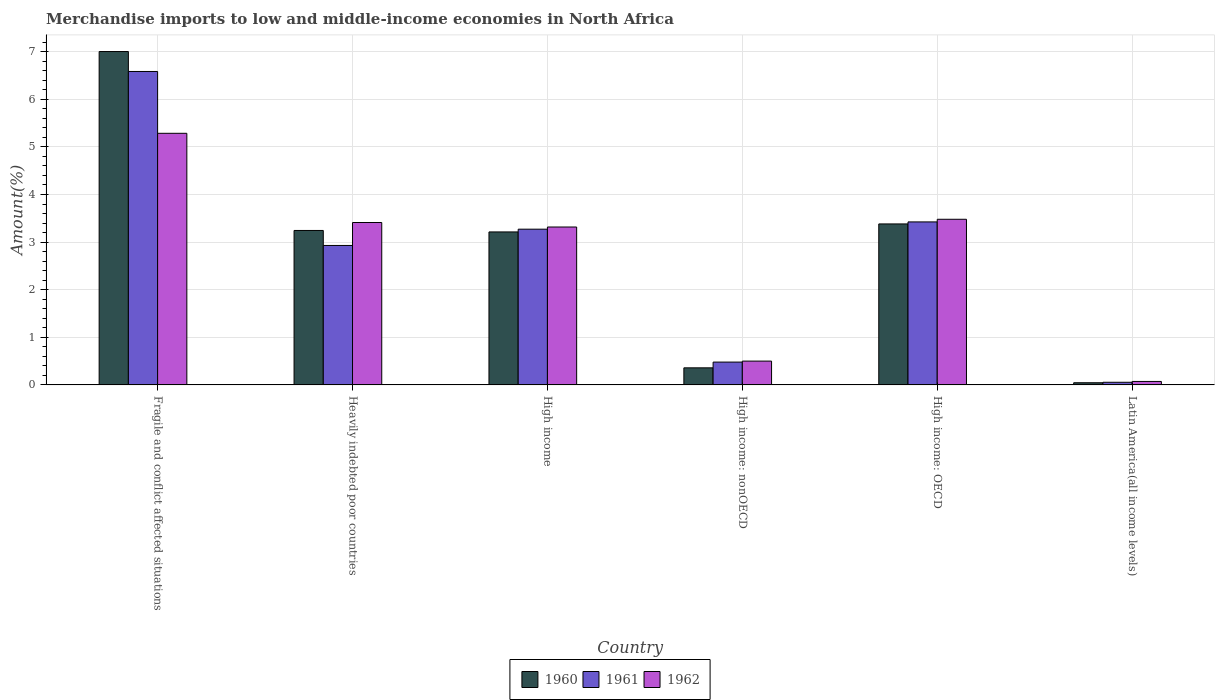Are the number of bars per tick equal to the number of legend labels?
Make the answer very short. Yes. How many bars are there on the 3rd tick from the right?
Give a very brief answer. 3. What is the label of the 5th group of bars from the left?
Keep it short and to the point. High income: OECD. In how many cases, is the number of bars for a given country not equal to the number of legend labels?
Your answer should be very brief. 0. What is the percentage of amount earned from merchandise imports in 1960 in Fragile and conflict affected situations?
Keep it short and to the point. 7. Across all countries, what is the maximum percentage of amount earned from merchandise imports in 1960?
Offer a terse response. 7. Across all countries, what is the minimum percentage of amount earned from merchandise imports in 1961?
Provide a short and direct response. 0.06. In which country was the percentage of amount earned from merchandise imports in 1960 maximum?
Your answer should be compact. Fragile and conflict affected situations. In which country was the percentage of amount earned from merchandise imports in 1960 minimum?
Your answer should be compact. Latin America(all income levels). What is the total percentage of amount earned from merchandise imports in 1962 in the graph?
Offer a very short reply. 16.07. What is the difference between the percentage of amount earned from merchandise imports in 1961 in Fragile and conflict affected situations and that in High income?
Your answer should be very brief. 3.31. What is the difference between the percentage of amount earned from merchandise imports in 1960 in Latin America(all income levels) and the percentage of amount earned from merchandise imports in 1962 in High income: nonOECD?
Offer a very short reply. -0.45. What is the average percentage of amount earned from merchandise imports in 1960 per country?
Provide a short and direct response. 2.87. What is the difference between the percentage of amount earned from merchandise imports of/in 1961 and percentage of amount earned from merchandise imports of/in 1962 in Fragile and conflict affected situations?
Offer a very short reply. 1.3. In how many countries, is the percentage of amount earned from merchandise imports in 1961 greater than 6.8 %?
Your response must be concise. 0. What is the ratio of the percentage of amount earned from merchandise imports in 1962 in Heavily indebted poor countries to that in High income: nonOECD?
Give a very brief answer. 6.82. Is the difference between the percentage of amount earned from merchandise imports in 1961 in Fragile and conflict affected situations and High income: nonOECD greater than the difference between the percentage of amount earned from merchandise imports in 1962 in Fragile and conflict affected situations and High income: nonOECD?
Your answer should be very brief. Yes. What is the difference between the highest and the second highest percentage of amount earned from merchandise imports in 1960?
Ensure brevity in your answer.  -0.14. What is the difference between the highest and the lowest percentage of amount earned from merchandise imports in 1961?
Ensure brevity in your answer.  6.53. Is the sum of the percentage of amount earned from merchandise imports in 1962 in High income and High income: OECD greater than the maximum percentage of amount earned from merchandise imports in 1961 across all countries?
Provide a succinct answer. Yes. What does the 2nd bar from the left in Fragile and conflict affected situations represents?
Your response must be concise. 1961. Are all the bars in the graph horizontal?
Ensure brevity in your answer.  No. Are the values on the major ticks of Y-axis written in scientific E-notation?
Your answer should be very brief. No. What is the title of the graph?
Make the answer very short. Merchandise imports to low and middle-income economies in North Africa. Does "2011" appear as one of the legend labels in the graph?
Ensure brevity in your answer.  No. What is the label or title of the X-axis?
Provide a short and direct response. Country. What is the label or title of the Y-axis?
Provide a short and direct response. Amount(%). What is the Amount(%) of 1960 in Fragile and conflict affected situations?
Your answer should be very brief. 7. What is the Amount(%) of 1961 in Fragile and conflict affected situations?
Offer a very short reply. 6.58. What is the Amount(%) in 1962 in Fragile and conflict affected situations?
Keep it short and to the point. 5.29. What is the Amount(%) of 1960 in Heavily indebted poor countries?
Your answer should be compact. 3.24. What is the Amount(%) in 1961 in Heavily indebted poor countries?
Your response must be concise. 2.93. What is the Amount(%) of 1962 in Heavily indebted poor countries?
Provide a short and direct response. 3.41. What is the Amount(%) of 1960 in High income?
Provide a short and direct response. 3.21. What is the Amount(%) of 1961 in High income?
Provide a succinct answer. 3.27. What is the Amount(%) of 1962 in High income?
Keep it short and to the point. 3.32. What is the Amount(%) of 1960 in High income: nonOECD?
Keep it short and to the point. 0.36. What is the Amount(%) in 1961 in High income: nonOECD?
Give a very brief answer. 0.48. What is the Amount(%) in 1962 in High income: nonOECD?
Offer a terse response. 0.5. What is the Amount(%) of 1960 in High income: OECD?
Give a very brief answer. 3.38. What is the Amount(%) in 1961 in High income: OECD?
Keep it short and to the point. 3.42. What is the Amount(%) of 1962 in High income: OECD?
Your answer should be compact. 3.48. What is the Amount(%) of 1960 in Latin America(all income levels)?
Keep it short and to the point. 0.05. What is the Amount(%) of 1961 in Latin America(all income levels)?
Your answer should be compact. 0.06. What is the Amount(%) in 1962 in Latin America(all income levels)?
Provide a short and direct response. 0.07. Across all countries, what is the maximum Amount(%) in 1960?
Give a very brief answer. 7. Across all countries, what is the maximum Amount(%) in 1961?
Offer a very short reply. 6.58. Across all countries, what is the maximum Amount(%) of 1962?
Give a very brief answer. 5.29. Across all countries, what is the minimum Amount(%) in 1960?
Offer a terse response. 0.05. Across all countries, what is the minimum Amount(%) in 1961?
Your answer should be very brief. 0.06. Across all countries, what is the minimum Amount(%) of 1962?
Give a very brief answer. 0.07. What is the total Amount(%) in 1960 in the graph?
Offer a terse response. 17.25. What is the total Amount(%) in 1961 in the graph?
Provide a short and direct response. 16.75. What is the total Amount(%) in 1962 in the graph?
Make the answer very short. 16.07. What is the difference between the Amount(%) of 1960 in Fragile and conflict affected situations and that in Heavily indebted poor countries?
Your response must be concise. 3.76. What is the difference between the Amount(%) in 1961 in Fragile and conflict affected situations and that in Heavily indebted poor countries?
Ensure brevity in your answer.  3.66. What is the difference between the Amount(%) of 1962 in Fragile and conflict affected situations and that in Heavily indebted poor countries?
Provide a short and direct response. 1.87. What is the difference between the Amount(%) of 1960 in Fragile and conflict affected situations and that in High income?
Your response must be concise. 3.79. What is the difference between the Amount(%) of 1961 in Fragile and conflict affected situations and that in High income?
Offer a very short reply. 3.31. What is the difference between the Amount(%) in 1962 in Fragile and conflict affected situations and that in High income?
Provide a short and direct response. 1.97. What is the difference between the Amount(%) of 1960 in Fragile and conflict affected situations and that in High income: nonOECD?
Provide a succinct answer. 6.64. What is the difference between the Amount(%) of 1961 in Fragile and conflict affected situations and that in High income: nonOECD?
Provide a succinct answer. 6.11. What is the difference between the Amount(%) of 1962 in Fragile and conflict affected situations and that in High income: nonOECD?
Offer a terse response. 4.79. What is the difference between the Amount(%) in 1960 in Fragile and conflict affected situations and that in High income: OECD?
Provide a short and direct response. 3.62. What is the difference between the Amount(%) of 1961 in Fragile and conflict affected situations and that in High income: OECD?
Ensure brevity in your answer.  3.16. What is the difference between the Amount(%) of 1962 in Fragile and conflict affected situations and that in High income: OECD?
Ensure brevity in your answer.  1.81. What is the difference between the Amount(%) of 1960 in Fragile and conflict affected situations and that in Latin America(all income levels)?
Provide a succinct answer. 6.96. What is the difference between the Amount(%) in 1961 in Fragile and conflict affected situations and that in Latin America(all income levels)?
Your answer should be compact. 6.53. What is the difference between the Amount(%) of 1962 in Fragile and conflict affected situations and that in Latin America(all income levels)?
Make the answer very short. 5.21. What is the difference between the Amount(%) of 1960 in Heavily indebted poor countries and that in High income?
Provide a succinct answer. 0.03. What is the difference between the Amount(%) of 1961 in Heavily indebted poor countries and that in High income?
Ensure brevity in your answer.  -0.34. What is the difference between the Amount(%) of 1962 in Heavily indebted poor countries and that in High income?
Offer a terse response. 0.09. What is the difference between the Amount(%) in 1960 in Heavily indebted poor countries and that in High income: nonOECD?
Give a very brief answer. 2.89. What is the difference between the Amount(%) of 1961 in Heavily indebted poor countries and that in High income: nonOECD?
Make the answer very short. 2.45. What is the difference between the Amount(%) in 1962 in Heavily indebted poor countries and that in High income: nonOECD?
Ensure brevity in your answer.  2.91. What is the difference between the Amount(%) of 1960 in Heavily indebted poor countries and that in High income: OECD?
Your answer should be very brief. -0.14. What is the difference between the Amount(%) in 1961 in Heavily indebted poor countries and that in High income: OECD?
Your response must be concise. -0.49. What is the difference between the Amount(%) of 1962 in Heavily indebted poor countries and that in High income: OECD?
Provide a short and direct response. -0.07. What is the difference between the Amount(%) of 1960 in Heavily indebted poor countries and that in Latin America(all income levels)?
Provide a succinct answer. 3.2. What is the difference between the Amount(%) of 1961 in Heavily indebted poor countries and that in Latin America(all income levels)?
Your answer should be very brief. 2.87. What is the difference between the Amount(%) of 1962 in Heavily indebted poor countries and that in Latin America(all income levels)?
Your response must be concise. 3.34. What is the difference between the Amount(%) in 1960 in High income and that in High income: nonOECD?
Your answer should be very brief. 2.86. What is the difference between the Amount(%) of 1961 in High income and that in High income: nonOECD?
Your answer should be compact. 2.79. What is the difference between the Amount(%) of 1962 in High income and that in High income: nonOECD?
Offer a terse response. 2.82. What is the difference between the Amount(%) of 1960 in High income and that in High income: OECD?
Your response must be concise. -0.17. What is the difference between the Amount(%) of 1961 in High income and that in High income: OECD?
Provide a short and direct response. -0.15. What is the difference between the Amount(%) of 1962 in High income and that in High income: OECD?
Provide a succinct answer. -0.16. What is the difference between the Amount(%) of 1960 in High income and that in Latin America(all income levels)?
Your answer should be very brief. 3.17. What is the difference between the Amount(%) of 1961 in High income and that in Latin America(all income levels)?
Give a very brief answer. 3.22. What is the difference between the Amount(%) of 1962 in High income and that in Latin America(all income levels)?
Make the answer very short. 3.24. What is the difference between the Amount(%) in 1960 in High income: nonOECD and that in High income: OECD?
Offer a terse response. -3.02. What is the difference between the Amount(%) of 1961 in High income: nonOECD and that in High income: OECD?
Your answer should be very brief. -2.94. What is the difference between the Amount(%) in 1962 in High income: nonOECD and that in High income: OECD?
Your response must be concise. -2.98. What is the difference between the Amount(%) of 1960 in High income: nonOECD and that in Latin America(all income levels)?
Offer a terse response. 0.31. What is the difference between the Amount(%) in 1961 in High income: nonOECD and that in Latin America(all income levels)?
Keep it short and to the point. 0.42. What is the difference between the Amount(%) of 1962 in High income: nonOECD and that in Latin America(all income levels)?
Your answer should be very brief. 0.43. What is the difference between the Amount(%) of 1960 in High income: OECD and that in Latin America(all income levels)?
Give a very brief answer. 3.34. What is the difference between the Amount(%) of 1961 in High income: OECD and that in Latin America(all income levels)?
Provide a succinct answer. 3.37. What is the difference between the Amount(%) in 1962 in High income: OECD and that in Latin America(all income levels)?
Provide a short and direct response. 3.41. What is the difference between the Amount(%) in 1960 in Fragile and conflict affected situations and the Amount(%) in 1961 in Heavily indebted poor countries?
Give a very brief answer. 4.07. What is the difference between the Amount(%) in 1960 in Fragile and conflict affected situations and the Amount(%) in 1962 in Heavily indebted poor countries?
Give a very brief answer. 3.59. What is the difference between the Amount(%) of 1961 in Fragile and conflict affected situations and the Amount(%) of 1962 in Heavily indebted poor countries?
Keep it short and to the point. 3.17. What is the difference between the Amount(%) of 1960 in Fragile and conflict affected situations and the Amount(%) of 1961 in High income?
Your answer should be compact. 3.73. What is the difference between the Amount(%) of 1960 in Fragile and conflict affected situations and the Amount(%) of 1962 in High income?
Your answer should be compact. 3.69. What is the difference between the Amount(%) of 1961 in Fragile and conflict affected situations and the Amount(%) of 1962 in High income?
Your answer should be very brief. 3.27. What is the difference between the Amount(%) of 1960 in Fragile and conflict affected situations and the Amount(%) of 1961 in High income: nonOECD?
Your response must be concise. 6.52. What is the difference between the Amount(%) of 1960 in Fragile and conflict affected situations and the Amount(%) of 1962 in High income: nonOECD?
Offer a very short reply. 6.5. What is the difference between the Amount(%) in 1961 in Fragile and conflict affected situations and the Amount(%) in 1962 in High income: nonOECD?
Keep it short and to the point. 6.08. What is the difference between the Amount(%) in 1960 in Fragile and conflict affected situations and the Amount(%) in 1961 in High income: OECD?
Offer a very short reply. 3.58. What is the difference between the Amount(%) in 1960 in Fragile and conflict affected situations and the Amount(%) in 1962 in High income: OECD?
Ensure brevity in your answer.  3.52. What is the difference between the Amount(%) of 1961 in Fragile and conflict affected situations and the Amount(%) of 1962 in High income: OECD?
Your answer should be very brief. 3.11. What is the difference between the Amount(%) in 1960 in Fragile and conflict affected situations and the Amount(%) in 1961 in Latin America(all income levels)?
Your answer should be very brief. 6.95. What is the difference between the Amount(%) of 1960 in Fragile and conflict affected situations and the Amount(%) of 1962 in Latin America(all income levels)?
Offer a terse response. 6.93. What is the difference between the Amount(%) of 1961 in Fragile and conflict affected situations and the Amount(%) of 1962 in Latin America(all income levels)?
Provide a short and direct response. 6.51. What is the difference between the Amount(%) of 1960 in Heavily indebted poor countries and the Amount(%) of 1961 in High income?
Provide a short and direct response. -0.03. What is the difference between the Amount(%) of 1960 in Heavily indebted poor countries and the Amount(%) of 1962 in High income?
Offer a very short reply. -0.07. What is the difference between the Amount(%) of 1961 in Heavily indebted poor countries and the Amount(%) of 1962 in High income?
Ensure brevity in your answer.  -0.39. What is the difference between the Amount(%) of 1960 in Heavily indebted poor countries and the Amount(%) of 1961 in High income: nonOECD?
Offer a very short reply. 2.77. What is the difference between the Amount(%) in 1960 in Heavily indebted poor countries and the Amount(%) in 1962 in High income: nonOECD?
Keep it short and to the point. 2.74. What is the difference between the Amount(%) in 1961 in Heavily indebted poor countries and the Amount(%) in 1962 in High income: nonOECD?
Provide a succinct answer. 2.43. What is the difference between the Amount(%) in 1960 in Heavily indebted poor countries and the Amount(%) in 1961 in High income: OECD?
Offer a terse response. -0.18. What is the difference between the Amount(%) in 1960 in Heavily indebted poor countries and the Amount(%) in 1962 in High income: OECD?
Offer a terse response. -0.23. What is the difference between the Amount(%) of 1961 in Heavily indebted poor countries and the Amount(%) of 1962 in High income: OECD?
Provide a succinct answer. -0.55. What is the difference between the Amount(%) of 1960 in Heavily indebted poor countries and the Amount(%) of 1961 in Latin America(all income levels)?
Keep it short and to the point. 3.19. What is the difference between the Amount(%) of 1960 in Heavily indebted poor countries and the Amount(%) of 1962 in Latin America(all income levels)?
Offer a terse response. 3.17. What is the difference between the Amount(%) of 1961 in Heavily indebted poor countries and the Amount(%) of 1962 in Latin America(all income levels)?
Provide a short and direct response. 2.86. What is the difference between the Amount(%) of 1960 in High income and the Amount(%) of 1961 in High income: nonOECD?
Make the answer very short. 2.73. What is the difference between the Amount(%) of 1960 in High income and the Amount(%) of 1962 in High income: nonOECD?
Make the answer very short. 2.71. What is the difference between the Amount(%) of 1961 in High income and the Amount(%) of 1962 in High income: nonOECD?
Ensure brevity in your answer.  2.77. What is the difference between the Amount(%) of 1960 in High income and the Amount(%) of 1961 in High income: OECD?
Make the answer very short. -0.21. What is the difference between the Amount(%) in 1960 in High income and the Amount(%) in 1962 in High income: OECD?
Provide a short and direct response. -0.27. What is the difference between the Amount(%) in 1961 in High income and the Amount(%) in 1962 in High income: OECD?
Provide a succinct answer. -0.21. What is the difference between the Amount(%) in 1960 in High income and the Amount(%) in 1961 in Latin America(all income levels)?
Your answer should be very brief. 3.16. What is the difference between the Amount(%) of 1960 in High income and the Amount(%) of 1962 in Latin America(all income levels)?
Ensure brevity in your answer.  3.14. What is the difference between the Amount(%) of 1961 in High income and the Amount(%) of 1962 in Latin America(all income levels)?
Your response must be concise. 3.2. What is the difference between the Amount(%) in 1960 in High income: nonOECD and the Amount(%) in 1961 in High income: OECD?
Your answer should be compact. -3.07. What is the difference between the Amount(%) of 1960 in High income: nonOECD and the Amount(%) of 1962 in High income: OECD?
Give a very brief answer. -3.12. What is the difference between the Amount(%) in 1961 in High income: nonOECD and the Amount(%) in 1962 in High income: OECD?
Your answer should be very brief. -3. What is the difference between the Amount(%) in 1960 in High income: nonOECD and the Amount(%) in 1961 in Latin America(all income levels)?
Offer a terse response. 0.3. What is the difference between the Amount(%) in 1960 in High income: nonOECD and the Amount(%) in 1962 in Latin America(all income levels)?
Make the answer very short. 0.29. What is the difference between the Amount(%) in 1961 in High income: nonOECD and the Amount(%) in 1962 in Latin America(all income levels)?
Your answer should be very brief. 0.41. What is the difference between the Amount(%) in 1960 in High income: OECD and the Amount(%) in 1961 in Latin America(all income levels)?
Keep it short and to the point. 3.33. What is the difference between the Amount(%) of 1960 in High income: OECD and the Amount(%) of 1962 in Latin America(all income levels)?
Make the answer very short. 3.31. What is the difference between the Amount(%) of 1961 in High income: OECD and the Amount(%) of 1962 in Latin America(all income levels)?
Give a very brief answer. 3.35. What is the average Amount(%) of 1960 per country?
Make the answer very short. 2.87. What is the average Amount(%) in 1961 per country?
Offer a very short reply. 2.79. What is the average Amount(%) of 1962 per country?
Offer a very short reply. 2.68. What is the difference between the Amount(%) of 1960 and Amount(%) of 1961 in Fragile and conflict affected situations?
Give a very brief answer. 0.42. What is the difference between the Amount(%) in 1960 and Amount(%) in 1962 in Fragile and conflict affected situations?
Provide a short and direct response. 1.72. What is the difference between the Amount(%) in 1961 and Amount(%) in 1962 in Fragile and conflict affected situations?
Give a very brief answer. 1.3. What is the difference between the Amount(%) of 1960 and Amount(%) of 1961 in Heavily indebted poor countries?
Your response must be concise. 0.32. What is the difference between the Amount(%) of 1960 and Amount(%) of 1962 in Heavily indebted poor countries?
Offer a terse response. -0.17. What is the difference between the Amount(%) of 1961 and Amount(%) of 1962 in Heavily indebted poor countries?
Your answer should be very brief. -0.48. What is the difference between the Amount(%) of 1960 and Amount(%) of 1961 in High income?
Provide a succinct answer. -0.06. What is the difference between the Amount(%) of 1960 and Amount(%) of 1962 in High income?
Give a very brief answer. -0.1. What is the difference between the Amount(%) of 1961 and Amount(%) of 1962 in High income?
Offer a very short reply. -0.05. What is the difference between the Amount(%) in 1960 and Amount(%) in 1961 in High income: nonOECD?
Your answer should be very brief. -0.12. What is the difference between the Amount(%) in 1960 and Amount(%) in 1962 in High income: nonOECD?
Make the answer very short. -0.14. What is the difference between the Amount(%) in 1961 and Amount(%) in 1962 in High income: nonOECD?
Make the answer very short. -0.02. What is the difference between the Amount(%) in 1960 and Amount(%) in 1961 in High income: OECD?
Offer a very short reply. -0.04. What is the difference between the Amount(%) in 1960 and Amount(%) in 1962 in High income: OECD?
Provide a succinct answer. -0.1. What is the difference between the Amount(%) of 1961 and Amount(%) of 1962 in High income: OECD?
Offer a very short reply. -0.06. What is the difference between the Amount(%) in 1960 and Amount(%) in 1961 in Latin America(all income levels)?
Provide a short and direct response. -0.01. What is the difference between the Amount(%) in 1960 and Amount(%) in 1962 in Latin America(all income levels)?
Your response must be concise. -0.03. What is the difference between the Amount(%) of 1961 and Amount(%) of 1962 in Latin America(all income levels)?
Your answer should be very brief. -0.02. What is the ratio of the Amount(%) of 1960 in Fragile and conflict affected situations to that in Heavily indebted poor countries?
Your response must be concise. 2.16. What is the ratio of the Amount(%) in 1961 in Fragile and conflict affected situations to that in Heavily indebted poor countries?
Offer a terse response. 2.25. What is the ratio of the Amount(%) in 1962 in Fragile and conflict affected situations to that in Heavily indebted poor countries?
Give a very brief answer. 1.55. What is the ratio of the Amount(%) in 1960 in Fragile and conflict affected situations to that in High income?
Offer a terse response. 2.18. What is the ratio of the Amount(%) in 1961 in Fragile and conflict affected situations to that in High income?
Your response must be concise. 2.01. What is the ratio of the Amount(%) in 1962 in Fragile and conflict affected situations to that in High income?
Provide a succinct answer. 1.59. What is the ratio of the Amount(%) in 1960 in Fragile and conflict affected situations to that in High income: nonOECD?
Make the answer very short. 19.53. What is the ratio of the Amount(%) of 1961 in Fragile and conflict affected situations to that in High income: nonOECD?
Your response must be concise. 13.73. What is the ratio of the Amount(%) of 1962 in Fragile and conflict affected situations to that in High income: nonOECD?
Provide a succinct answer. 10.57. What is the ratio of the Amount(%) of 1960 in Fragile and conflict affected situations to that in High income: OECD?
Your response must be concise. 2.07. What is the ratio of the Amount(%) in 1961 in Fragile and conflict affected situations to that in High income: OECD?
Ensure brevity in your answer.  1.92. What is the ratio of the Amount(%) in 1962 in Fragile and conflict affected situations to that in High income: OECD?
Offer a terse response. 1.52. What is the ratio of the Amount(%) in 1960 in Fragile and conflict affected situations to that in Latin America(all income levels)?
Your response must be concise. 153.43. What is the ratio of the Amount(%) in 1961 in Fragile and conflict affected situations to that in Latin America(all income levels)?
Your answer should be very brief. 118.81. What is the ratio of the Amount(%) of 1962 in Fragile and conflict affected situations to that in Latin America(all income levels)?
Your response must be concise. 72.58. What is the ratio of the Amount(%) of 1960 in Heavily indebted poor countries to that in High income?
Offer a terse response. 1.01. What is the ratio of the Amount(%) in 1961 in Heavily indebted poor countries to that in High income?
Provide a succinct answer. 0.9. What is the ratio of the Amount(%) in 1962 in Heavily indebted poor countries to that in High income?
Provide a short and direct response. 1.03. What is the ratio of the Amount(%) in 1960 in Heavily indebted poor countries to that in High income: nonOECD?
Make the answer very short. 9.05. What is the ratio of the Amount(%) of 1961 in Heavily indebted poor countries to that in High income: nonOECD?
Give a very brief answer. 6.11. What is the ratio of the Amount(%) of 1962 in Heavily indebted poor countries to that in High income: nonOECD?
Provide a short and direct response. 6.82. What is the ratio of the Amount(%) of 1960 in Heavily indebted poor countries to that in High income: OECD?
Your answer should be very brief. 0.96. What is the ratio of the Amount(%) of 1961 in Heavily indebted poor countries to that in High income: OECD?
Provide a succinct answer. 0.86. What is the ratio of the Amount(%) of 1962 in Heavily indebted poor countries to that in High income: OECD?
Provide a succinct answer. 0.98. What is the ratio of the Amount(%) in 1960 in Heavily indebted poor countries to that in Latin America(all income levels)?
Your response must be concise. 71.08. What is the ratio of the Amount(%) in 1961 in Heavily indebted poor countries to that in Latin America(all income levels)?
Your answer should be very brief. 52.86. What is the ratio of the Amount(%) in 1962 in Heavily indebted poor countries to that in Latin America(all income levels)?
Your response must be concise. 46.85. What is the ratio of the Amount(%) in 1960 in High income to that in High income: nonOECD?
Your answer should be compact. 8.96. What is the ratio of the Amount(%) in 1961 in High income to that in High income: nonOECD?
Offer a terse response. 6.82. What is the ratio of the Amount(%) of 1962 in High income to that in High income: nonOECD?
Provide a succinct answer. 6.63. What is the ratio of the Amount(%) of 1960 in High income to that in High income: OECD?
Your answer should be compact. 0.95. What is the ratio of the Amount(%) of 1961 in High income to that in High income: OECD?
Ensure brevity in your answer.  0.96. What is the ratio of the Amount(%) in 1962 in High income to that in High income: OECD?
Keep it short and to the point. 0.95. What is the ratio of the Amount(%) of 1960 in High income to that in Latin America(all income levels)?
Keep it short and to the point. 70.4. What is the ratio of the Amount(%) in 1961 in High income to that in Latin America(all income levels)?
Provide a short and direct response. 59.03. What is the ratio of the Amount(%) in 1962 in High income to that in Latin America(all income levels)?
Offer a terse response. 45.55. What is the ratio of the Amount(%) of 1960 in High income: nonOECD to that in High income: OECD?
Provide a succinct answer. 0.11. What is the ratio of the Amount(%) in 1961 in High income: nonOECD to that in High income: OECD?
Ensure brevity in your answer.  0.14. What is the ratio of the Amount(%) in 1962 in High income: nonOECD to that in High income: OECD?
Ensure brevity in your answer.  0.14. What is the ratio of the Amount(%) in 1960 in High income: nonOECD to that in Latin America(all income levels)?
Make the answer very short. 7.86. What is the ratio of the Amount(%) in 1961 in High income: nonOECD to that in Latin America(all income levels)?
Provide a short and direct response. 8.65. What is the ratio of the Amount(%) of 1962 in High income: nonOECD to that in Latin America(all income levels)?
Keep it short and to the point. 6.87. What is the ratio of the Amount(%) in 1960 in High income: OECD to that in Latin America(all income levels)?
Your response must be concise. 74.09. What is the ratio of the Amount(%) of 1961 in High income: OECD to that in Latin America(all income levels)?
Keep it short and to the point. 61.78. What is the ratio of the Amount(%) in 1962 in High income: OECD to that in Latin America(all income levels)?
Provide a succinct answer. 47.78. What is the difference between the highest and the second highest Amount(%) in 1960?
Offer a very short reply. 3.62. What is the difference between the highest and the second highest Amount(%) in 1961?
Offer a terse response. 3.16. What is the difference between the highest and the second highest Amount(%) in 1962?
Offer a terse response. 1.81. What is the difference between the highest and the lowest Amount(%) in 1960?
Ensure brevity in your answer.  6.96. What is the difference between the highest and the lowest Amount(%) of 1961?
Keep it short and to the point. 6.53. What is the difference between the highest and the lowest Amount(%) in 1962?
Your answer should be compact. 5.21. 